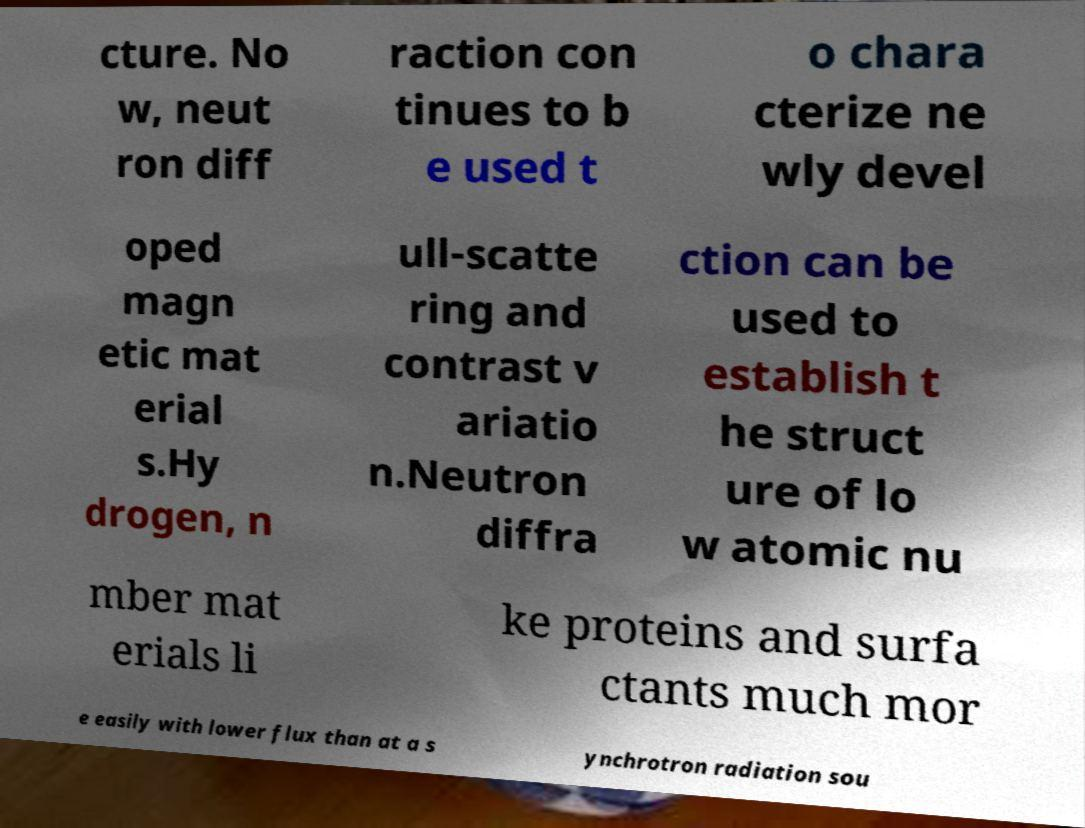There's text embedded in this image that I need extracted. Can you transcribe it verbatim? cture. No w, neut ron diff raction con tinues to b e used t o chara cterize ne wly devel oped magn etic mat erial s.Hy drogen, n ull-scatte ring and contrast v ariatio n.Neutron diffra ction can be used to establish t he struct ure of lo w atomic nu mber mat erials li ke proteins and surfa ctants much mor e easily with lower flux than at a s ynchrotron radiation sou 